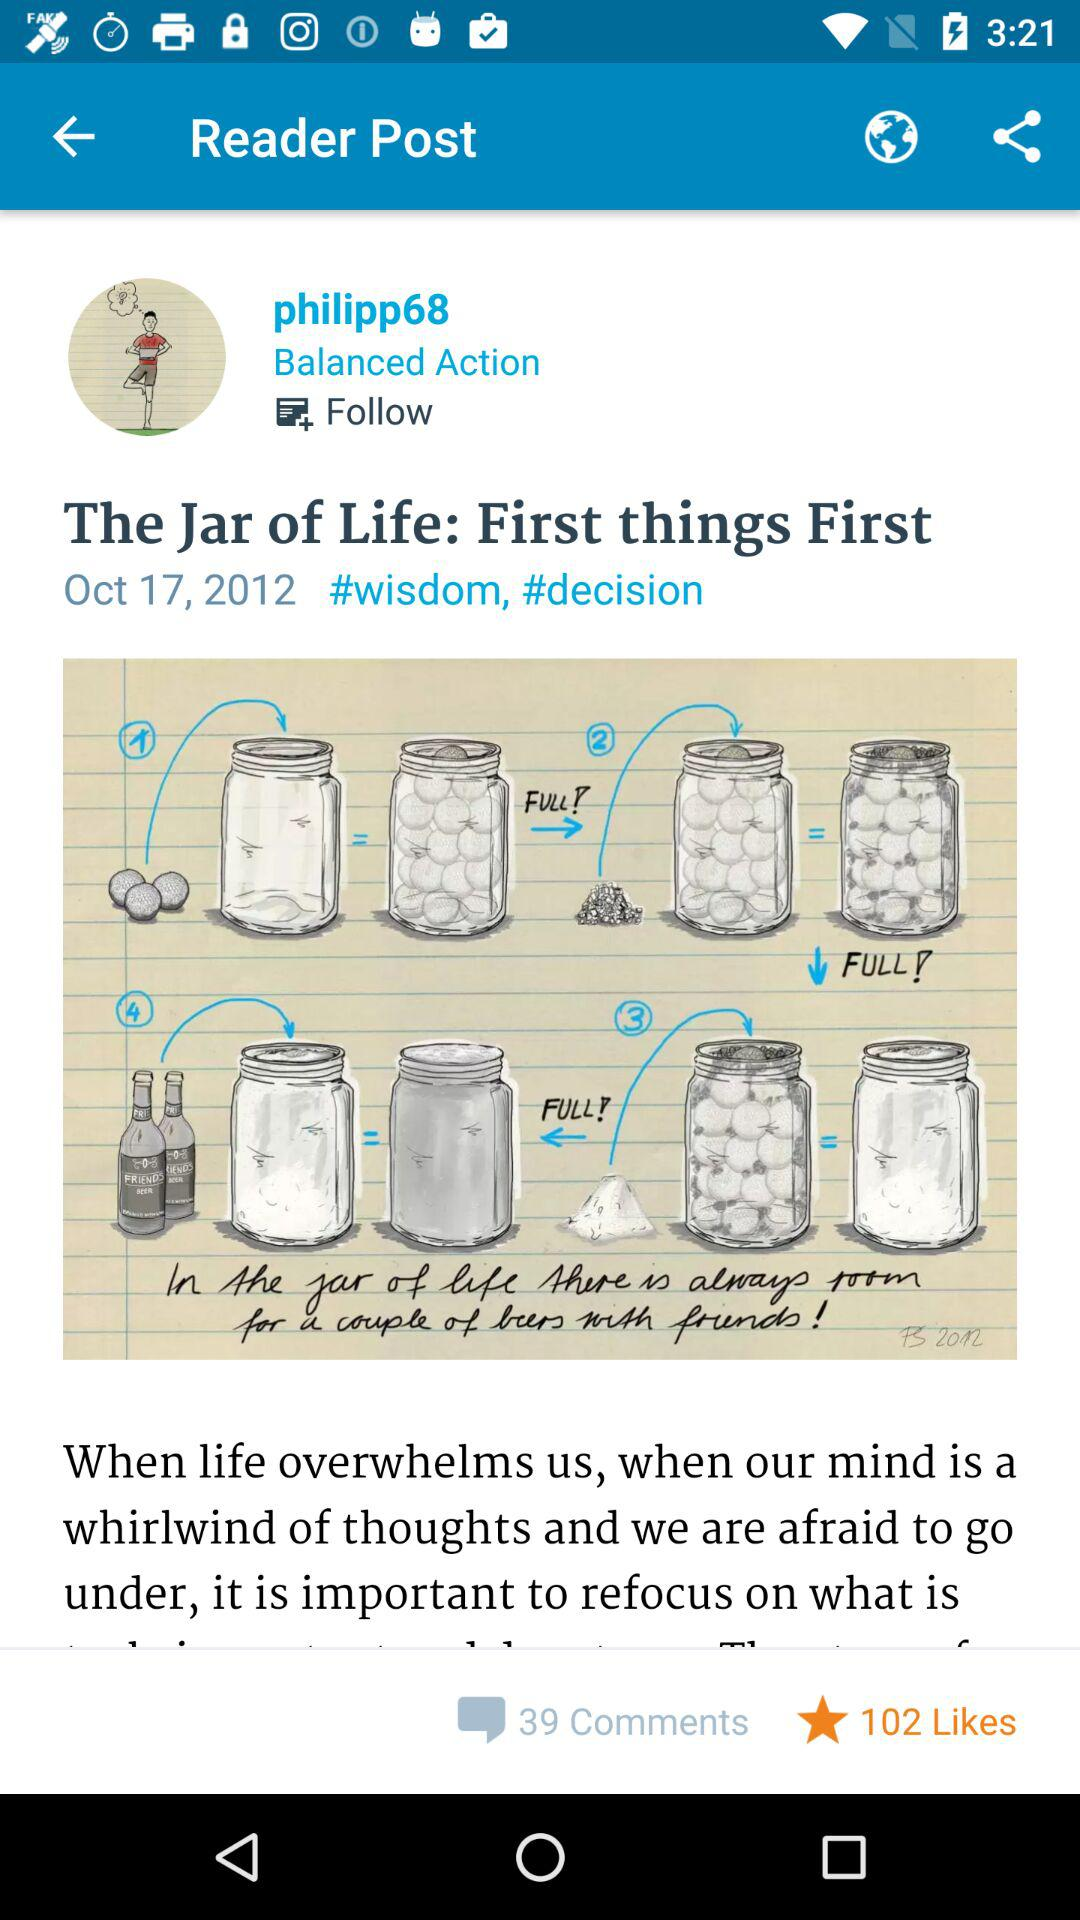How many more likes than comments does this post have?
Answer the question using a single word or phrase. 63 